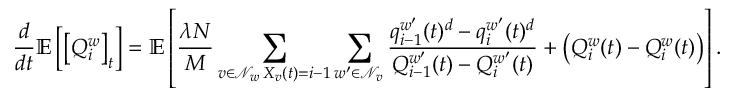Convert formula to latex. <formula><loc_0><loc_0><loc_500><loc_500>\frac { d } { d t } \mathbb { E } \left [ \left [ Q _ { i } ^ { w } \right ] _ { t } \right ] = \mathbb { E } \left [ \frac { \lambda N } { M } \sum _ { \substack { v \in \mathcal { N } _ { w } \, X _ { v } ( t ) = i - 1 } } \sum _ { w ^ { \prime } \in \mathcal { N } _ { v } } \frac { q _ { i - 1 } ^ { w ^ { \prime } } ( t ) ^ { d } - q _ { i } ^ { w ^ { \prime } } ( t ) ^ { d } } { Q _ { i - 1 } ^ { w ^ { \prime } } ( t ) - Q _ { i } ^ { w ^ { \prime } } ( t ) } + \left ( Q _ { i } ^ { w } ( t ) - Q _ { i } ^ { w } ( t ) \right ) \right ] .</formula> 